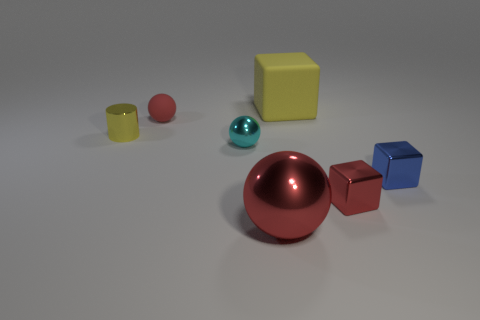Subtract all red cubes. How many cubes are left? 2 Subtract all cyan spheres. How many spheres are left? 2 Add 3 small cyan metallic things. How many objects exist? 10 Add 5 tiny cyan objects. How many tiny cyan objects exist? 6 Subtract 1 yellow cubes. How many objects are left? 6 Subtract all spheres. How many objects are left? 4 Subtract 1 blocks. How many blocks are left? 2 Subtract all yellow balls. Subtract all yellow cubes. How many balls are left? 3 Subtract all cyan cubes. How many red spheres are left? 2 Subtract all large yellow matte cubes. Subtract all red shiny objects. How many objects are left? 4 